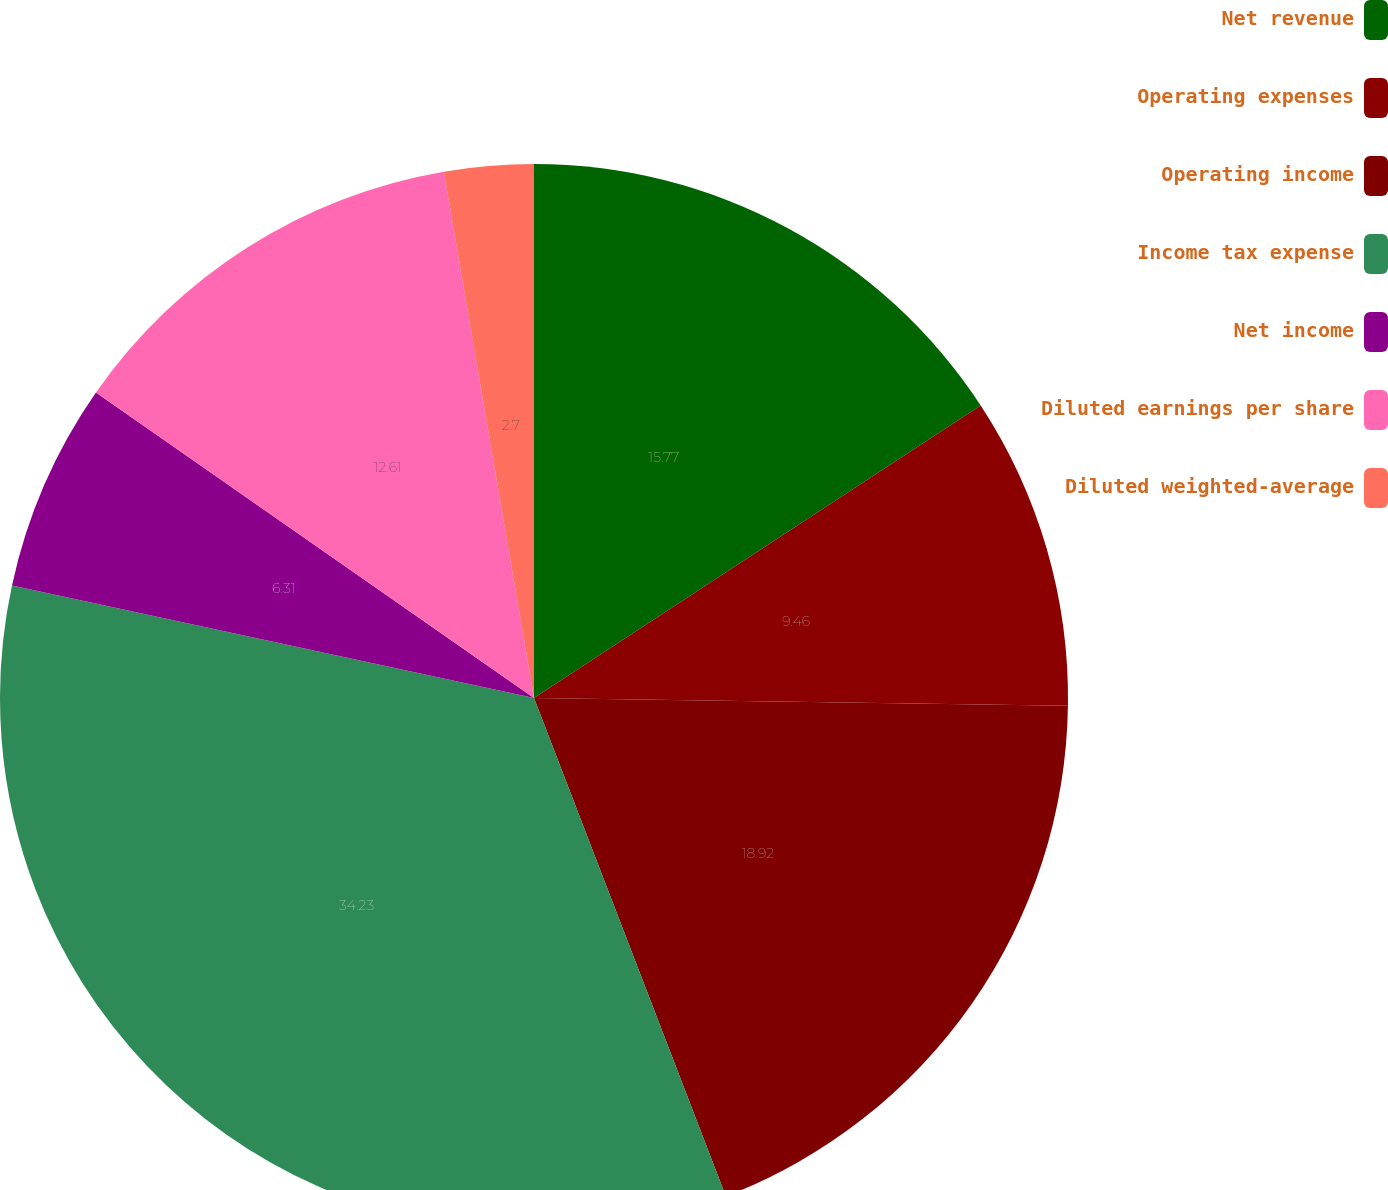<chart> <loc_0><loc_0><loc_500><loc_500><pie_chart><fcel>Net revenue<fcel>Operating expenses<fcel>Operating income<fcel>Income tax expense<fcel>Net income<fcel>Diluted earnings per share<fcel>Diluted weighted-average<nl><fcel>15.77%<fcel>9.46%<fcel>18.92%<fcel>34.23%<fcel>6.31%<fcel>12.61%<fcel>2.7%<nl></chart> 